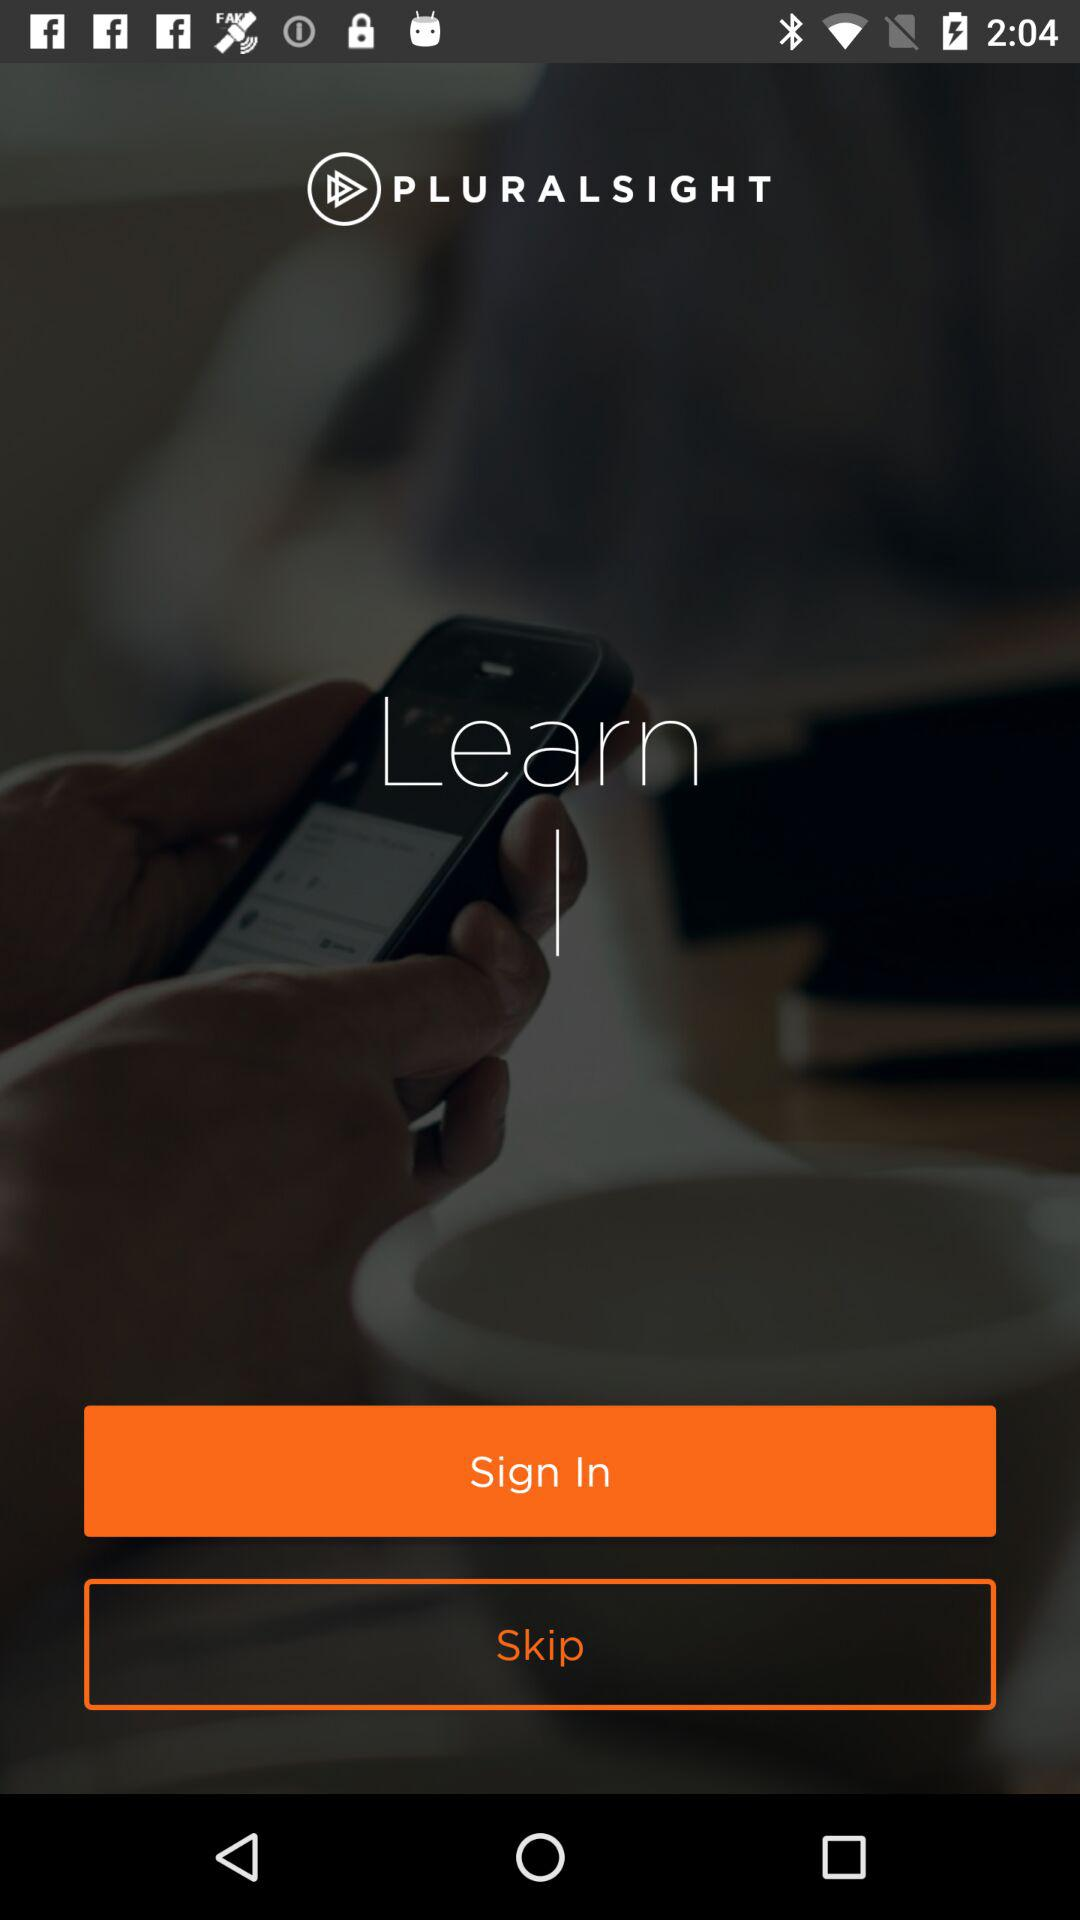What is the app name? The app name is "PLURALSIGHT". 